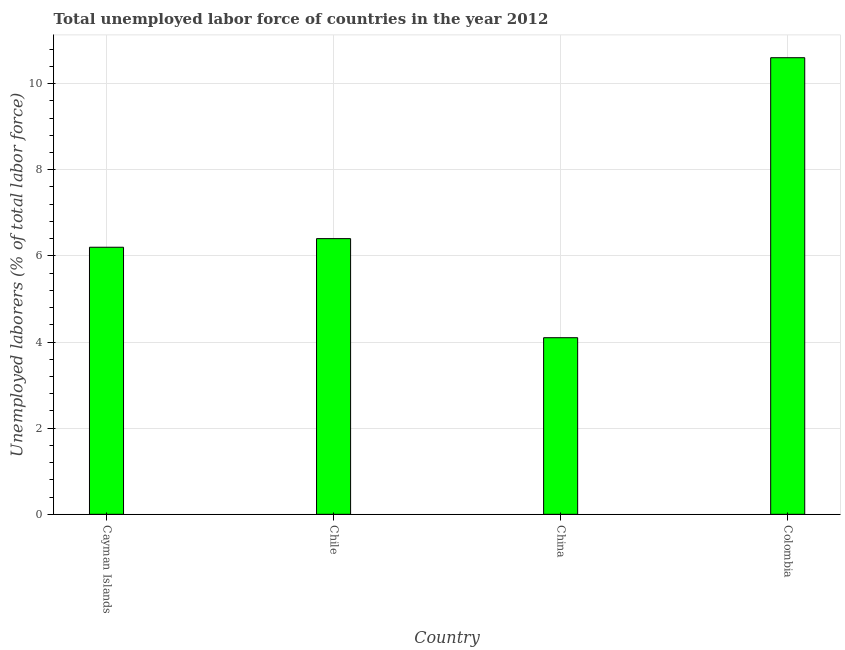Does the graph contain any zero values?
Your answer should be very brief. No. Does the graph contain grids?
Make the answer very short. Yes. What is the title of the graph?
Offer a very short reply. Total unemployed labor force of countries in the year 2012. What is the label or title of the X-axis?
Your answer should be very brief. Country. What is the label or title of the Y-axis?
Ensure brevity in your answer.  Unemployed laborers (% of total labor force). What is the total unemployed labour force in China?
Give a very brief answer. 4.1. Across all countries, what is the maximum total unemployed labour force?
Ensure brevity in your answer.  10.6. Across all countries, what is the minimum total unemployed labour force?
Make the answer very short. 4.1. In which country was the total unemployed labour force maximum?
Give a very brief answer. Colombia. What is the sum of the total unemployed labour force?
Ensure brevity in your answer.  27.3. What is the average total unemployed labour force per country?
Ensure brevity in your answer.  6.83. What is the median total unemployed labour force?
Ensure brevity in your answer.  6.3. What is the difference between the highest and the second highest total unemployed labour force?
Provide a succinct answer. 4.2. What is the difference between the highest and the lowest total unemployed labour force?
Ensure brevity in your answer.  6.5. In how many countries, is the total unemployed labour force greater than the average total unemployed labour force taken over all countries?
Give a very brief answer. 1. What is the Unemployed laborers (% of total labor force) of Cayman Islands?
Give a very brief answer. 6.2. What is the Unemployed laborers (% of total labor force) in Chile?
Your answer should be very brief. 6.4. What is the Unemployed laborers (% of total labor force) in China?
Offer a terse response. 4.1. What is the Unemployed laborers (% of total labor force) of Colombia?
Your answer should be compact. 10.6. What is the difference between the Unemployed laborers (% of total labor force) in Cayman Islands and China?
Offer a very short reply. 2.1. What is the difference between the Unemployed laborers (% of total labor force) in Cayman Islands and Colombia?
Offer a very short reply. -4.4. What is the difference between the Unemployed laborers (% of total labor force) in Chile and Colombia?
Keep it short and to the point. -4.2. What is the ratio of the Unemployed laborers (% of total labor force) in Cayman Islands to that in China?
Your answer should be very brief. 1.51. What is the ratio of the Unemployed laborers (% of total labor force) in Cayman Islands to that in Colombia?
Ensure brevity in your answer.  0.58. What is the ratio of the Unemployed laborers (% of total labor force) in Chile to that in China?
Ensure brevity in your answer.  1.56. What is the ratio of the Unemployed laborers (% of total labor force) in Chile to that in Colombia?
Offer a terse response. 0.6. What is the ratio of the Unemployed laborers (% of total labor force) in China to that in Colombia?
Provide a succinct answer. 0.39. 